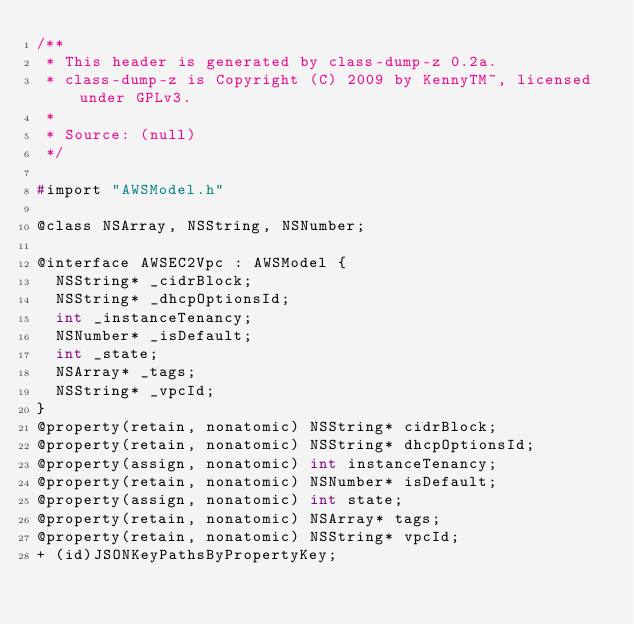<code> <loc_0><loc_0><loc_500><loc_500><_C_>/**
 * This header is generated by class-dump-z 0.2a.
 * class-dump-z is Copyright (C) 2009 by KennyTM~, licensed under GPLv3.
 *
 * Source: (null)
 */

#import "AWSModel.h"

@class NSArray, NSString, NSNumber;

@interface AWSEC2Vpc : AWSModel {
	NSString* _cidrBlock;
	NSString* _dhcpOptionsId;
	int _instanceTenancy;
	NSNumber* _isDefault;
	int _state;
	NSArray* _tags;
	NSString* _vpcId;
}
@property(retain, nonatomic) NSString* cidrBlock;
@property(retain, nonatomic) NSString* dhcpOptionsId;
@property(assign, nonatomic) int instanceTenancy;
@property(retain, nonatomic) NSNumber* isDefault;
@property(assign, nonatomic) int state;
@property(retain, nonatomic) NSArray* tags;
@property(retain, nonatomic) NSString* vpcId;
+ (id)JSONKeyPathsByPropertyKey;</code> 